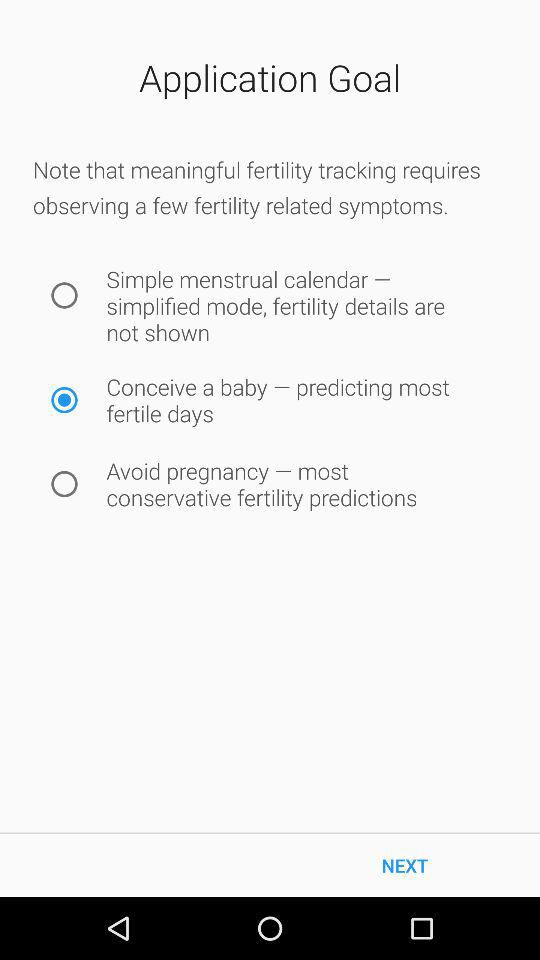Which symptom is selected for fertility tracking? The selected symptom is "Conceive a baby – predicting most fertile days". 